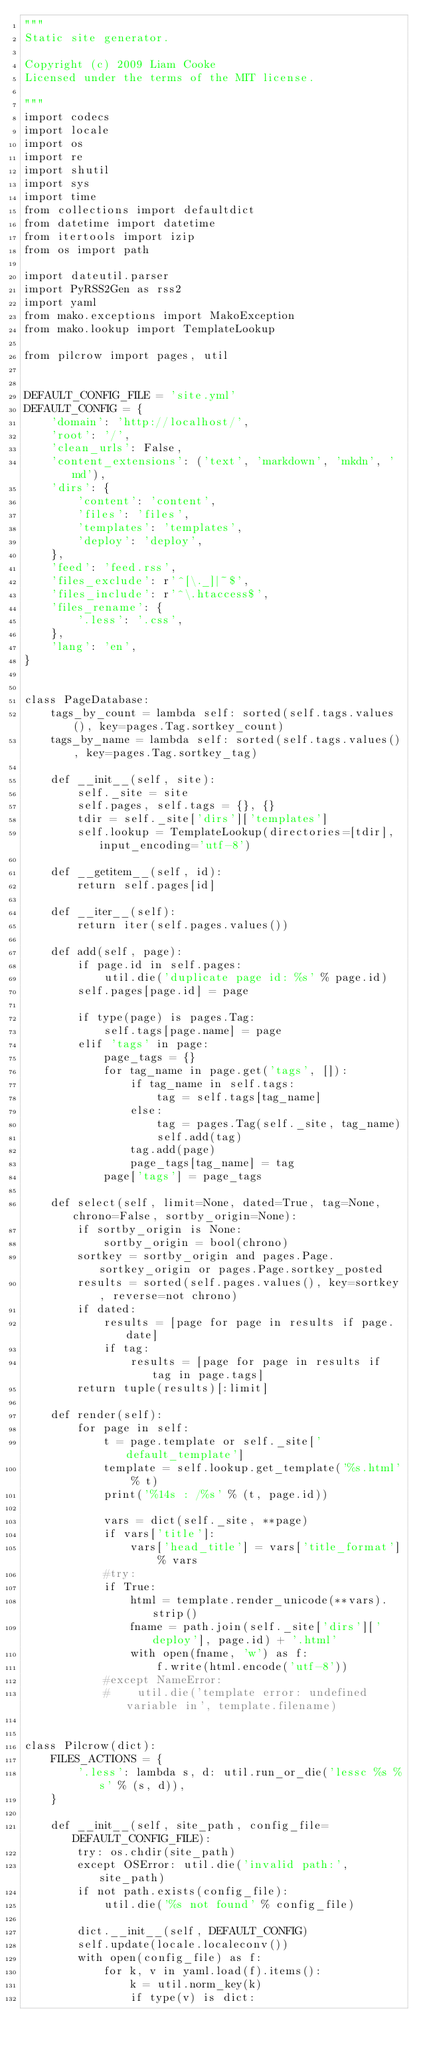Convert code to text. <code><loc_0><loc_0><loc_500><loc_500><_Python_>"""
Static site generator.

Copyright (c) 2009 Liam Cooke
Licensed under the terms of the MIT license.

"""
import codecs
import locale
import os
import re
import shutil
import sys
import time
from collections import defaultdict
from datetime import datetime
from itertools import izip
from os import path

import dateutil.parser
import PyRSS2Gen as rss2
import yaml
from mako.exceptions import MakoException
from mako.lookup import TemplateLookup

from pilcrow import pages, util


DEFAULT_CONFIG_FILE = 'site.yml'
DEFAULT_CONFIG = {
    'domain': 'http://localhost/',
    'root': '/',
    'clean_urls': False,
    'content_extensions': ('text', 'markdown', 'mkdn', 'md'),
    'dirs': {
        'content': 'content',
        'files': 'files',
        'templates': 'templates',
        'deploy': 'deploy',
    },
    'feed': 'feed.rss',
    'files_exclude': r'^[\._]|~$',
    'files_include': r'^\.htaccess$',
    'files_rename': {
        '.less': '.css',
    },
    'lang': 'en',
}


class PageDatabase:
    tags_by_count = lambda self: sorted(self.tags.values(), key=pages.Tag.sortkey_count)
    tags_by_name = lambda self: sorted(self.tags.values(), key=pages.Tag.sortkey_tag)

    def __init__(self, site):
        self._site = site
        self.pages, self.tags = {}, {}
        tdir = self._site['dirs']['templates']
        self.lookup = TemplateLookup(directories=[tdir], input_encoding='utf-8')

    def __getitem__(self, id):
        return self.pages[id]

    def __iter__(self):
        return iter(self.pages.values())

    def add(self, page):
        if page.id in self.pages:
            util.die('duplicate page id: %s' % page.id)
        self.pages[page.id] = page

        if type(page) is pages.Tag:
            self.tags[page.name] = page
        elif 'tags' in page:
            page_tags = {}
            for tag_name in page.get('tags', []):
                if tag_name in self.tags:
                    tag = self.tags[tag_name]
                else:
                    tag = pages.Tag(self._site, tag_name)
                    self.add(tag)
                tag.add(page)
                page_tags[tag_name] = tag
            page['tags'] = page_tags

    def select(self, limit=None, dated=True, tag=None, chrono=False, sortby_origin=None):
        if sortby_origin is None:
            sortby_origin = bool(chrono)
        sortkey = sortby_origin and pages.Page.sortkey_origin or pages.Page.sortkey_posted
        results = sorted(self.pages.values(), key=sortkey, reverse=not chrono)
        if dated:
            results = [page for page in results if page.date]
            if tag:
                results = [page for page in results if tag in page.tags]
        return tuple(results)[:limit]

    def render(self):
        for page in self:
            t = page.template or self._site['default_template']
            template = self.lookup.get_template('%s.html' % t)
            print('%14s : /%s' % (t, page.id))

            vars = dict(self._site, **page)
            if vars['title']:
                vars['head_title'] = vars['title_format'] % vars
            #try:
            if True:
                html = template.render_unicode(**vars).strip()
                fname = path.join(self._site['dirs']['deploy'], page.id) + '.html'
                with open(fname, 'w') as f:
                    f.write(html.encode('utf-8'))
            #except NameError:
            #    util.die('template error: undefined variable in', template.filename)


class Pilcrow(dict):
    FILES_ACTIONS = {
        '.less': lambda s, d: util.run_or_die('lessc %s %s' % (s, d)),
    }

    def __init__(self, site_path, config_file=DEFAULT_CONFIG_FILE):
        try: os.chdir(site_path)
        except OSError: util.die('invalid path:', site_path)
        if not path.exists(config_file):
            util.die('%s not found' % config_file)

        dict.__init__(self, DEFAULT_CONFIG)
        self.update(locale.localeconv())
        with open(config_file) as f:
            for k, v in yaml.load(f).items():
                k = util.norm_key(k)
                if type(v) is dict:</code> 